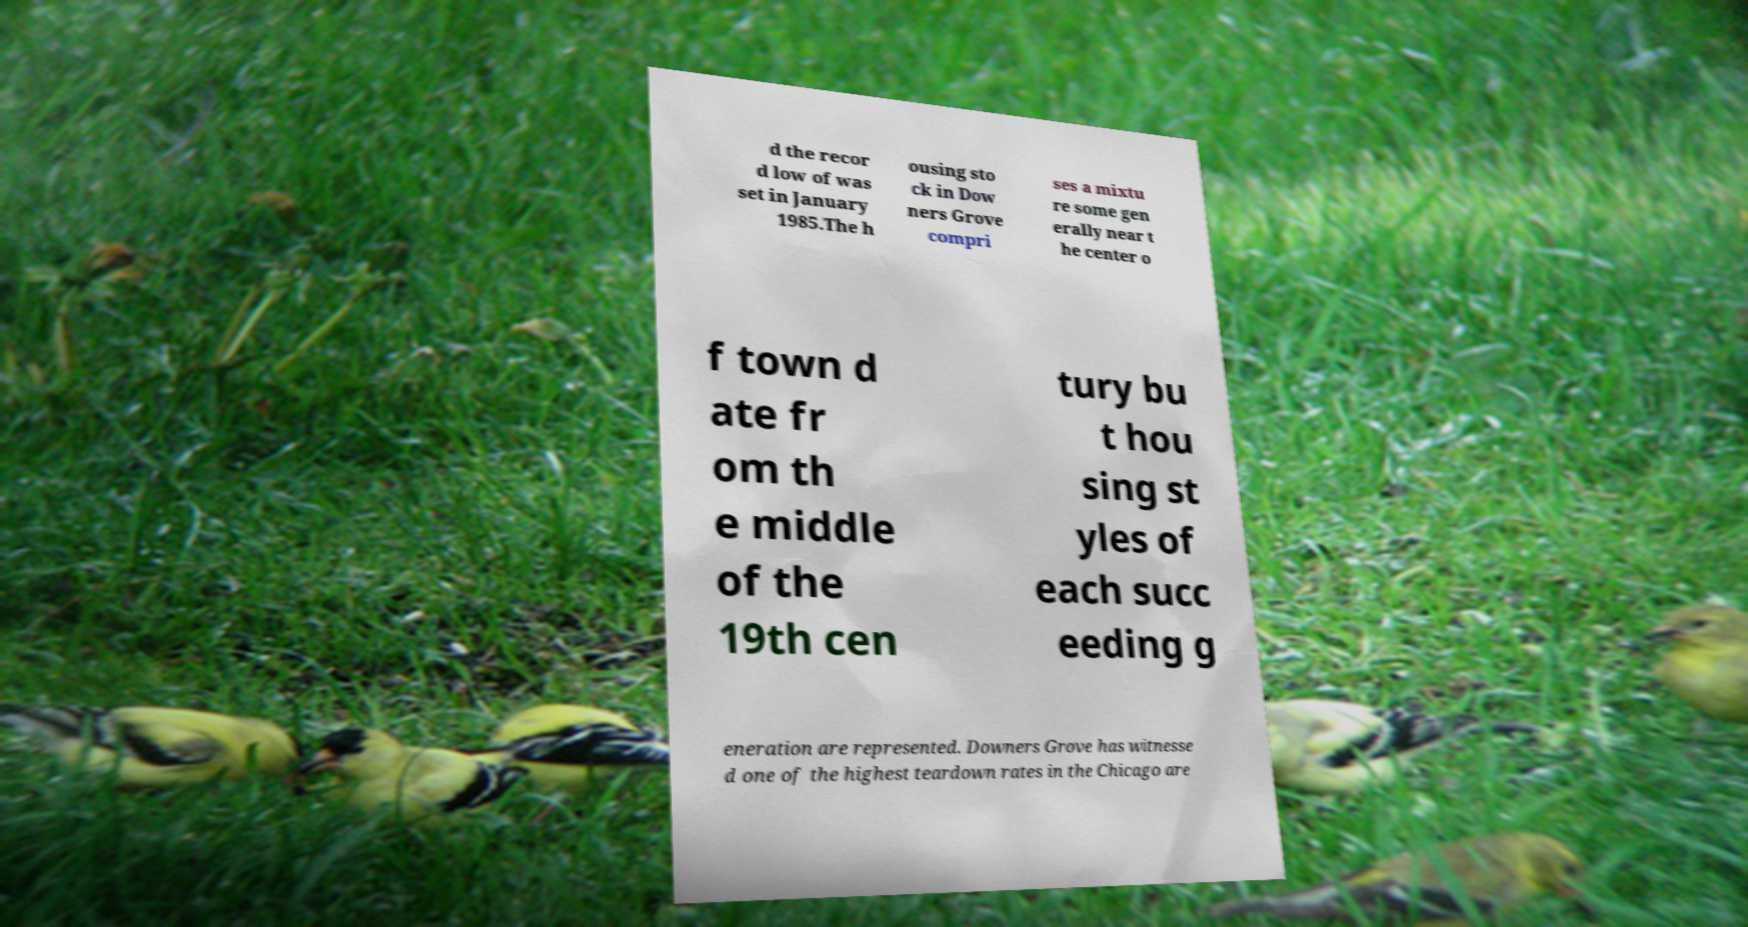There's text embedded in this image that I need extracted. Can you transcribe it verbatim? d the recor d low of was set in January 1985.The h ousing sto ck in Dow ners Grove compri ses a mixtu re some gen erally near t he center o f town d ate fr om th e middle of the 19th cen tury bu t hou sing st yles of each succ eeding g eneration are represented. Downers Grove has witnesse d one of the highest teardown rates in the Chicago are 